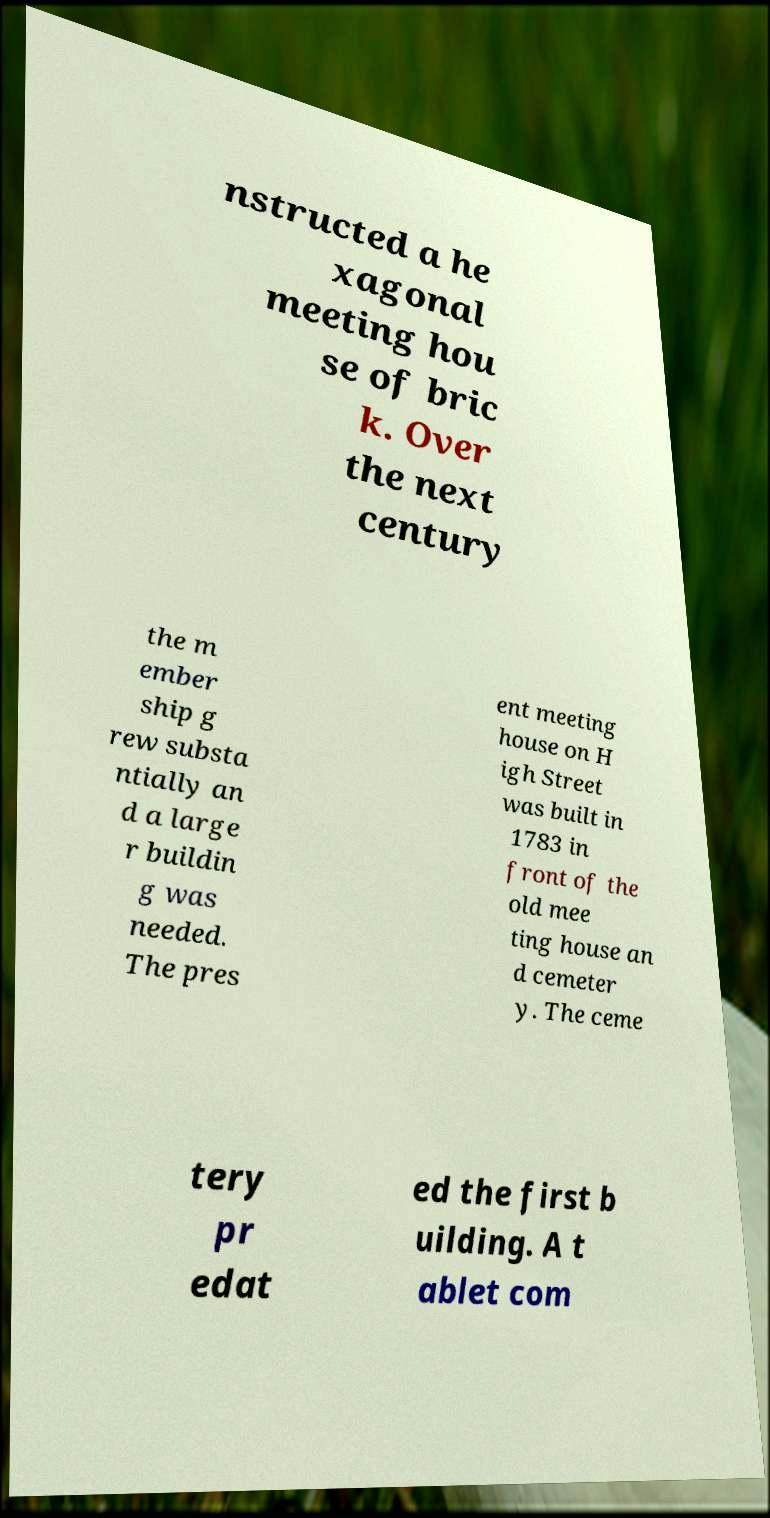Can you read and provide the text displayed in the image?This photo seems to have some interesting text. Can you extract and type it out for me? nstructed a he xagonal meeting hou se of bric k. Over the next century the m ember ship g rew substa ntially an d a large r buildin g was needed. The pres ent meeting house on H igh Street was built in 1783 in front of the old mee ting house an d cemeter y. The ceme tery pr edat ed the first b uilding. A t ablet com 